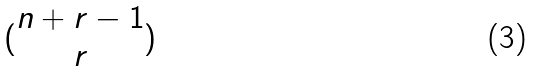<formula> <loc_0><loc_0><loc_500><loc_500>( \begin{matrix} n + r - 1 \\ r \end{matrix} )</formula> 